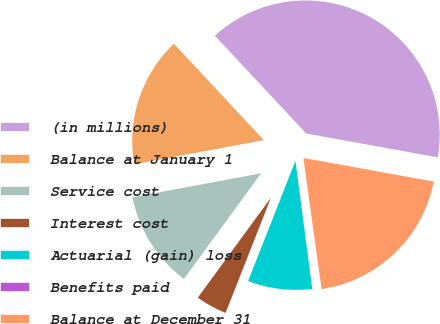Convert chart. <chart><loc_0><loc_0><loc_500><loc_500><pie_chart><fcel>(in millions)<fcel>Balance at January 1<fcel>Service cost<fcel>Interest cost<fcel>Actuarial (gain) loss<fcel>Benefits paid<fcel>Balance at December 31<nl><fcel>39.81%<fcel>15.99%<fcel>12.02%<fcel>4.08%<fcel>8.05%<fcel>0.11%<fcel>19.96%<nl></chart> 